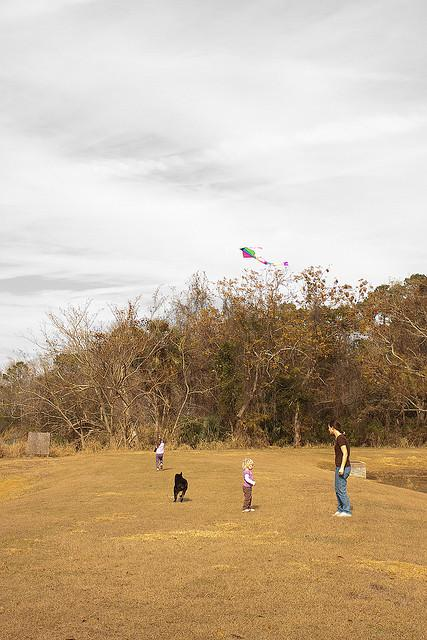What breed dog it is?

Choices:
A) poodle
B) pug
C) dachshund
D) cane corso cane corso 